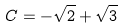Convert formula to latex. <formula><loc_0><loc_0><loc_500><loc_500>C = - \sqrt { 2 } + \sqrt { 3 }</formula> 